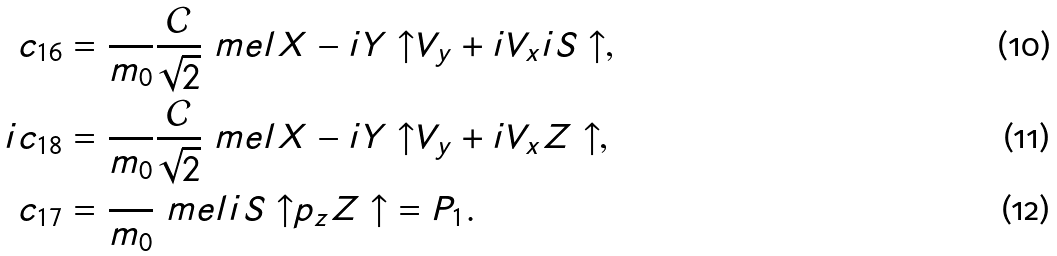<formula> <loc_0><loc_0><loc_500><loc_500>{ c _ { 1 6 } } & = \frac { } { m _ { 0 } } \frac { \mathcal { C } } { \sqrt { 2 } } \ m e l { X - i Y \uparrow } { V _ { y } + i V _ { x } } { i S \uparrow } , \\ { i c _ { 1 8 } } & = \frac { } { m _ { 0 } } \frac { \mathcal { C } } { \sqrt { 2 } } \ m e l { X - i Y \uparrow } { V _ { y } + i V _ { x } } { Z \uparrow } , \\ c _ { 1 7 } & = \frac { } { m _ { 0 } } \ m e l { i S \uparrow } { p _ { z } } { Z \uparrow } = P _ { 1 } .</formula> 